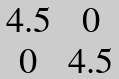Convert formula to latex. <formula><loc_0><loc_0><loc_500><loc_500>\begin{matrix} 4 . 5 & 0 \\ 0 & 4 . 5 \\ \end{matrix}</formula> 